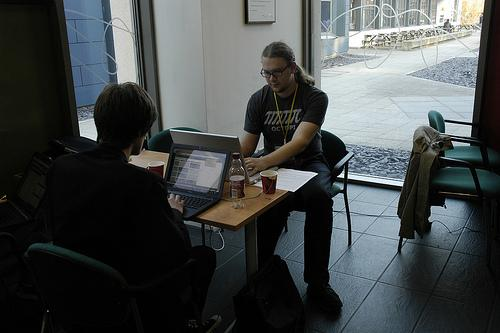Mention any cloth item present in the room and where it is placed. A tan jacket is hanging on the back of a green chair. Talk about the seating arrangement present in the image. There are two green chairs with green cushions in the room. Tell me something about a man's appearance and what he is wearing. The man is wearing glasses and has long hair tied in a ponytail. Identify two objects on the table apart from the laptops and mention their colors. There is a brown cup and a black bottle on the table. Identify the two people in the image and what activity they are engaged in. Two men are sitting at a table using their laptop computers. What are the two objects on the table that are being used by the men? The two men are using a black laptop and a silver laptop on the table. Mention the color and type of flooring in the image. The floor is made of black ceramic tiles. Describe an object located on the table and what it can be used for. There is an empty plastic beverage bottle on the table which can be used for drinking. What is the color of the wall and what can be seen on it? The wall is white in color, and there are white graphics on a large window. What can be seen outside the window in the image? A view of the sidewalk and gray stones can be seen from inside the building. 